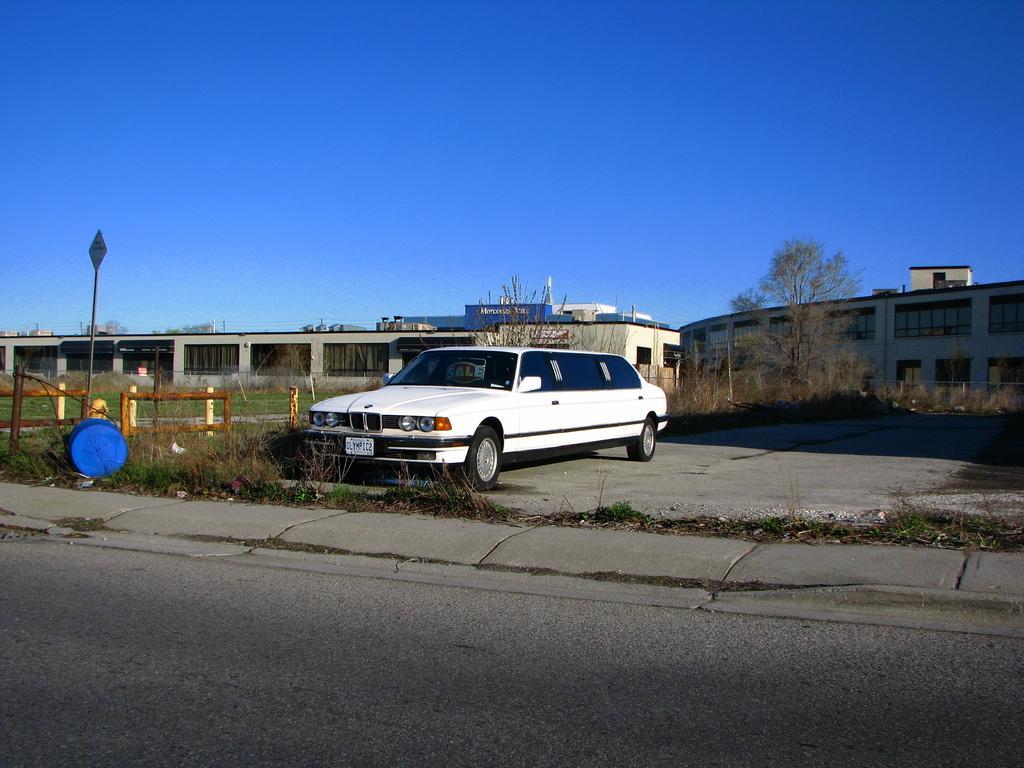Describe this image in one or two sentences. In the foreground of the picture there are shrubs, grass, pavement and road. In the center of the picture there are plants, grass, railing, sign board, drum and a car. In the background there are buildings and trees. Sky is sunny. 